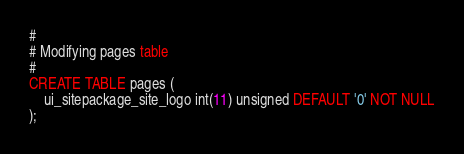<code> <loc_0><loc_0><loc_500><loc_500><_SQL_>#
# Modifying pages table
#
CREATE TABLE pages (
    ui_sitepackage_site_logo int(11) unsigned DEFAULT '0' NOT NULL
);
</code> 